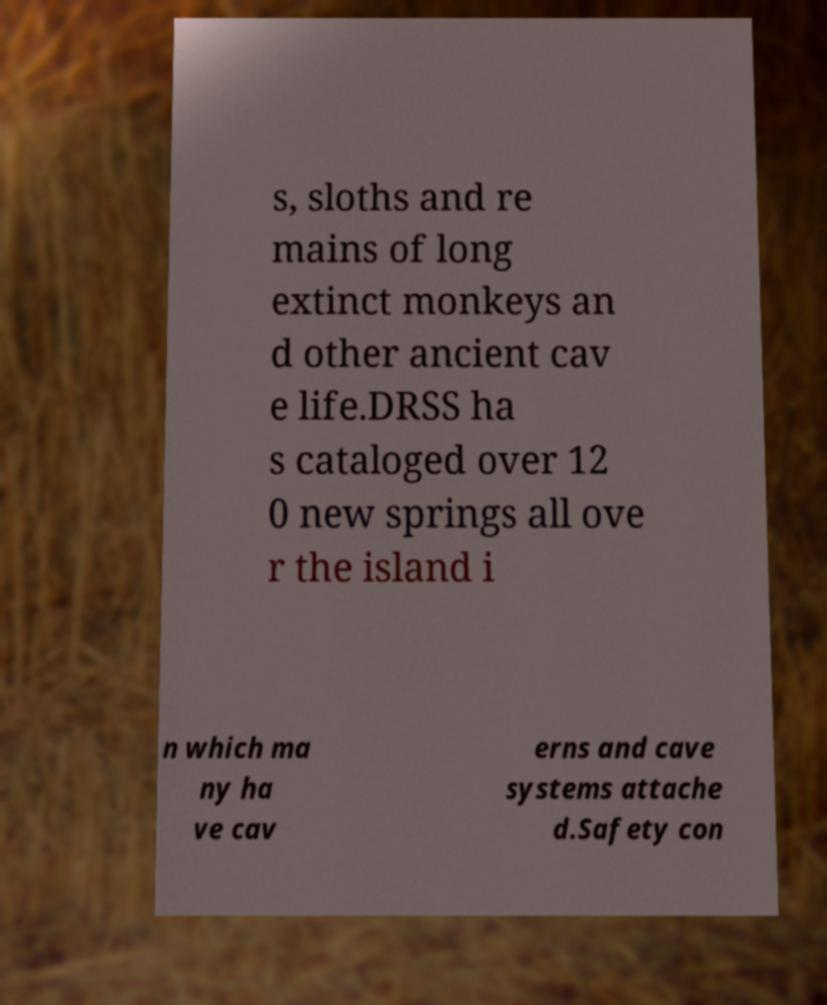Could you assist in decoding the text presented in this image and type it out clearly? s, sloths and re mains of long extinct monkeys an d other ancient cav e life.DRSS ha s cataloged over 12 0 new springs all ove r the island i n which ma ny ha ve cav erns and cave systems attache d.Safety con 